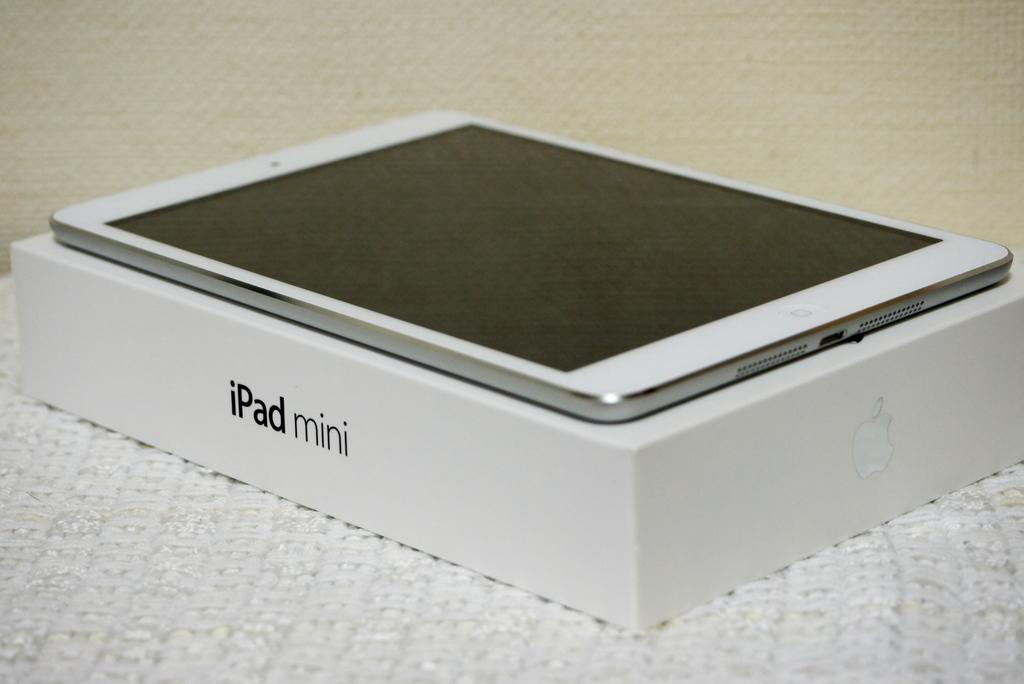<image>
Render a clear and concise summary of the photo. A pad is on top of an iPad mini box. 